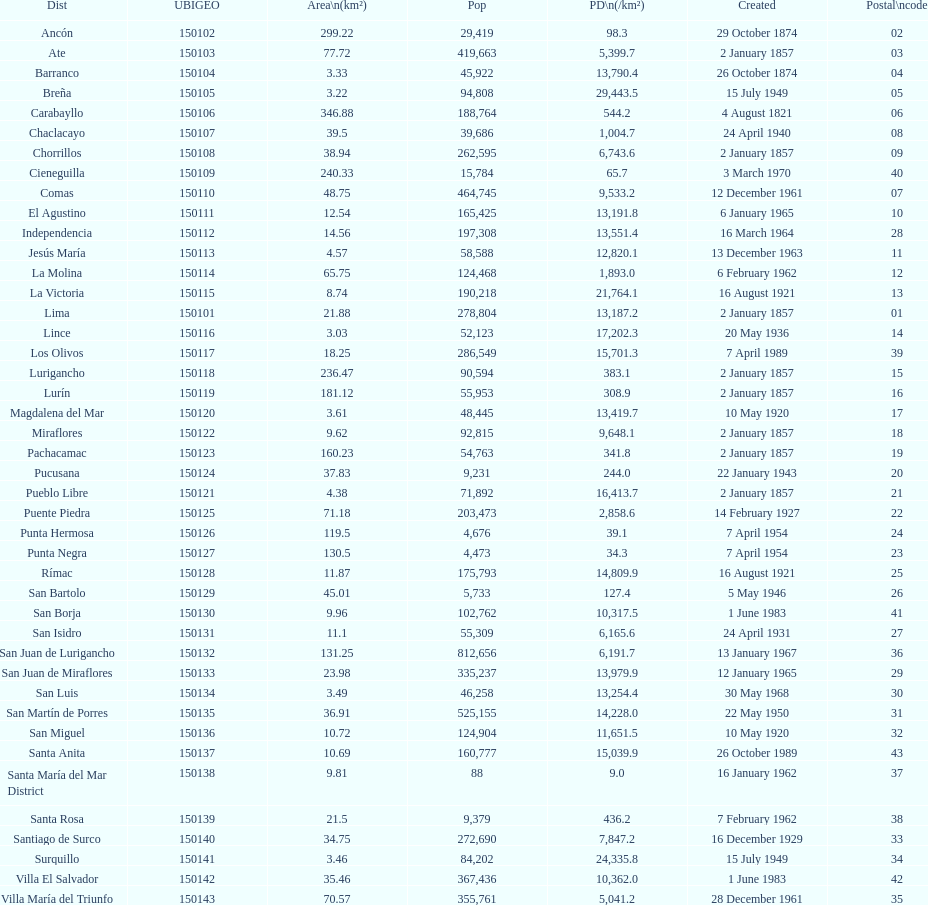What is the overall count of districts established in the 1900's? 32. 